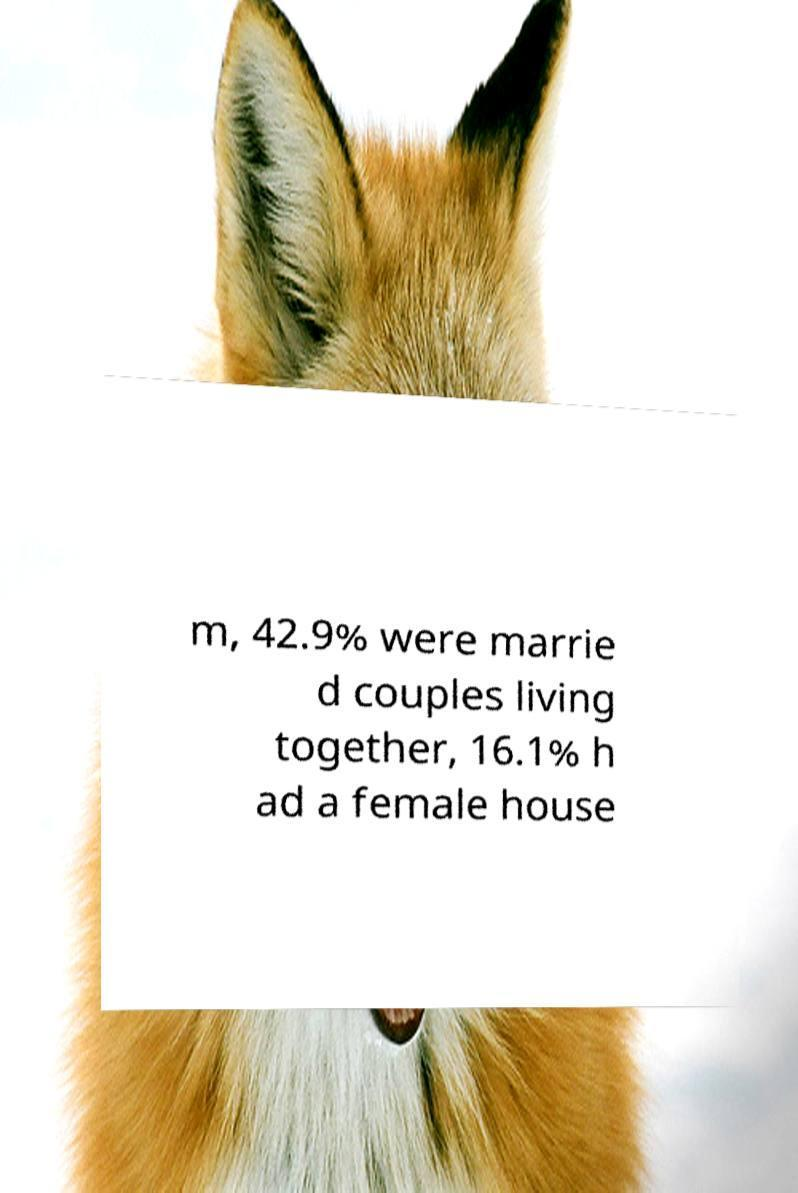Please identify and transcribe the text found in this image. m, 42.9% were marrie d couples living together, 16.1% h ad a female house 